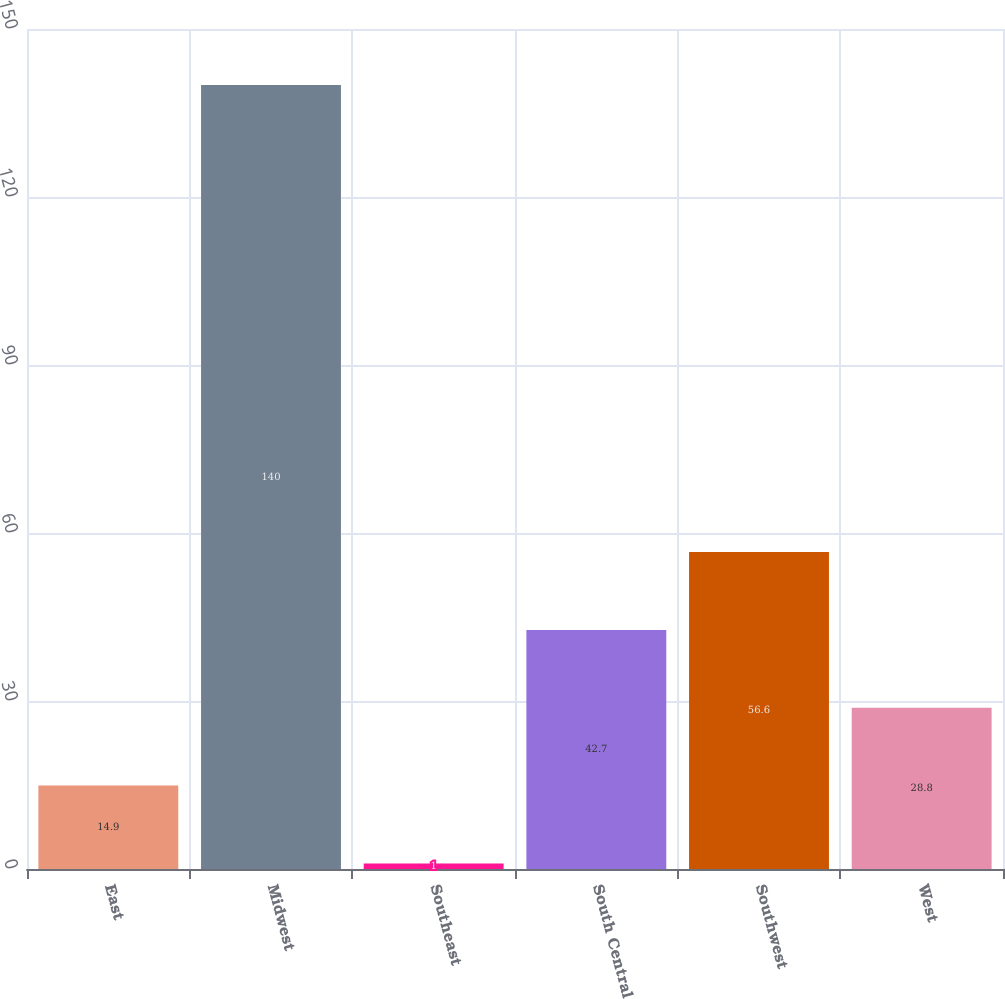<chart> <loc_0><loc_0><loc_500><loc_500><bar_chart><fcel>East<fcel>Midwest<fcel>Southeast<fcel>South Central<fcel>Southwest<fcel>West<nl><fcel>14.9<fcel>140<fcel>1<fcel>42.7<fcel>56.6<fcel>28.8<nl></chart> 